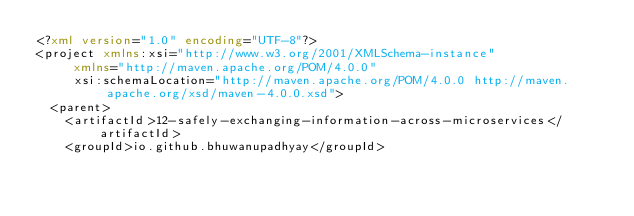<code> <loc_0><loc_0><loc_500><loc_500><_XML_><?xml version="1.0" encoding="UTF-8"?>
<project xmlns:xsi="http://www.w3.org/2001/XMLSchema-instance"
		 xmlns="http://maven.apache.org/POM/4.0.0"
		 xsi:schemaLocation="http://maven.apache.org/POM/4.0.0 http://maven.apache.org/xsd/maven-4.0.0.xsd">
	<parent>
		<artifactId>12-safely-exchanging-information-across-microservices</artifactId>
		<groupId>io.github.bhuwanupadhyay</groupId></code> 